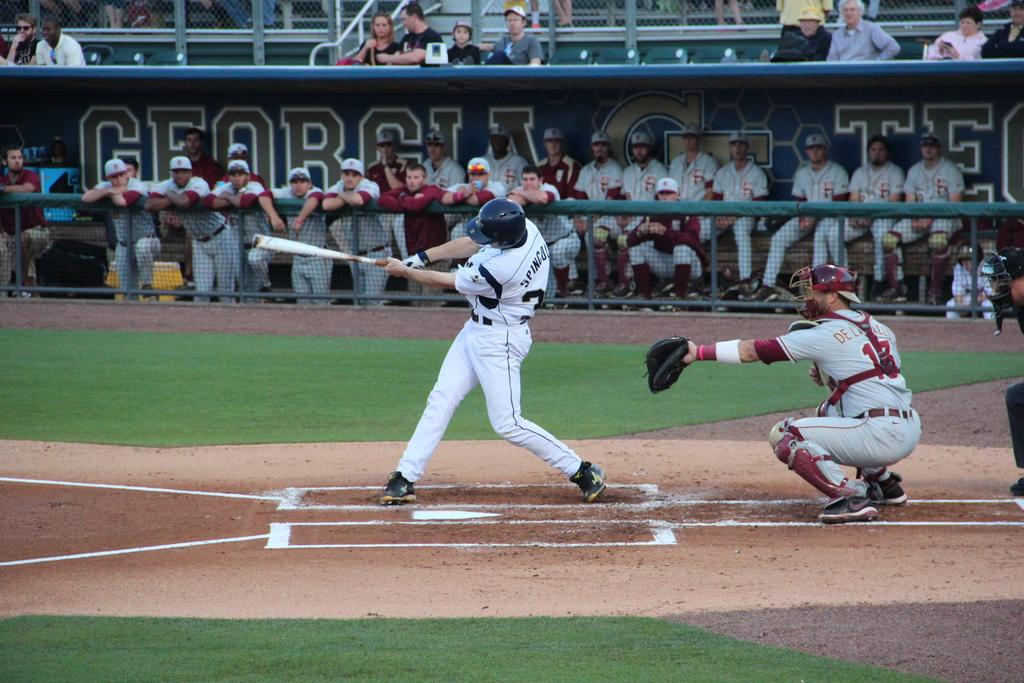<image>
Relay a brief, clear account of the picture shown. A baseball game is going on at the Georgia Tech field. 